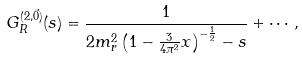<formula> <loc_0><loc_0><loc_500><loc_500>G ^ { ( 2 , \vec { 0 } ) } _ { R } ( s ) & = \frac { 1 } { 2 m _ { r } ^ { 2 } \left ( 1 - \frac { 3 } { 4 \pi ^ { 2 } } x \right ) ^ { - \frac { 1 } { 2 } } - s } + \cdots ,</formula> 